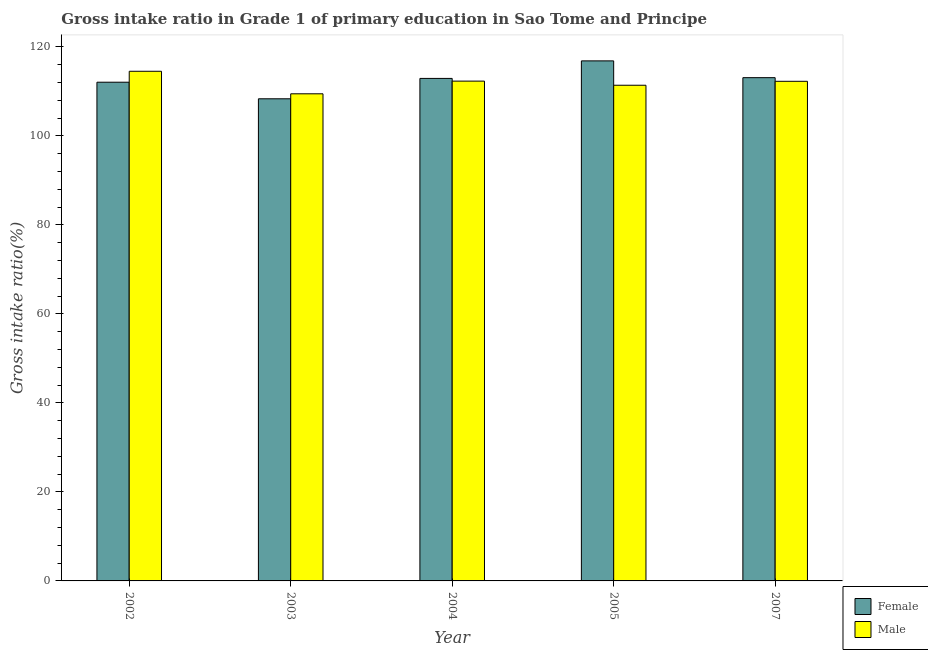How many different coloured bars are there?
Make the answer very short. 2. Are the number of bars on each tick of the X-axis equal?
Provide a succinct answer. Yes. How many bars are there on the 4th tick from the left?
Give a very brief answer. 2. How many bars are there on the 2nd tick from the right?
Offer a terse response. 2. In how many cases, is the number of bars for a given year not equal to the number of legend labels?
Your answer should be compact. 0. What is the gross intake ratio(male) in 2007?
Offer a very short reply. 112.26. Across all years, what is the maximum gross intake ratio(female)?
Provide a short and direct response. 116.85. Across all years, what is the minimum gross intake ratio(female)?
Keep it short and to the point. 108.33. What is the total gross intake ratio(male) in the graph?
Your answer should be very brief. 559.91. What is the difference between the gross intake ratio(male) in 2002 and that in 2007?
Keep it short and to the point. 2.26. What is the difference between the gross intake ratio(female) in 2007 and the gross intake ratio(male) in 2002?
Your answer should be very brief. 1.02. What is the average gross intake ratio(male) per year?
Give a very brief answer. 111.98. What is the ratio of the gross intake ratio(female) in 2003 to that in 2007?
Make the answer very short. 0.96. What is the difference between the highest and the second highest gross intake ratio(female)?
Provide a succinct answer. 3.77. What is the difference between the highest and the lowest gross intake ratio(female)?
Your answer should be compact. 8.52. In how many years, is the gross intake ratio(female) greater than the average gross intake ratio(female) taken over all years?
Your answer should be compact. 3. What does the 2nd bar from the left in 2004 represents?
Provide a short and direct response. Male. Are the values on the major ticks of Y-axis written in scientific E-notation?
Provide a short and direct response. No. What is the title of the graph?
Your answer should be compact. Gross intake ratio in Grade 1 of primary education in Sao Tome and Principe. What is the label or title of the Y-axis?
Ensure brevity in your answer.  Gross intake ratio(%). What is the Gross intake ratio(%) of Female in 2002?
Provide a short and direct response. 112.06. What is the Gross intake ratio(%) of Male in 2002?
Provide a short and direct response. 114.52. What is the Gross intake ratio(%) of Female in 2003?
Ensure brevity in your answer.  108.33. What is the Gross intake ratio(%) of Male in 2003?
Offer a very short reply. 109.45. What is the Gross intake ratio(%) of Female in 2004?
Your answer should be compact. 112.91. What is the Gross intake ratio(%) in Male in 2004?
Ensure brevity in your answer.  112.3. What is the Gross intake ratio(%) of Female in 2005?
Ensure brevity in your answer.  116.85. What is the Gross intake ratio(%) of Male in 2005?
Give a very brief answer. 111.38. What is the Gross intake ratio(%) of Female in 2007?
Offer a very short reply. 113.08. What is the Gross intake ratio(%) of Male in 2007?
Offer a terse response. 112.26. Across all years, what is the maximum Gross intake ratio(%) of Female?
Offer a terse response. 116.85. Across all years, what is the maximum Gross intake ratio(%) of Male?
Your response must be concise. 114.52. Across all years, what is the minimum Gross intake ratio(%) of Female?
Your answer should be very brief. 108.33. Across all years, what is the minimum Gross intake ratio(%) in Male?
Your answer should be compact. 109.45. What is the total Gross intake ratio(%) of Female in the graph?
Your response must be concise. 563.23. What is the total Gross intake ratio(%) in Male in the graph?
Offer a terse response. 559.91. What is the difference between the Gross intake ratio(%) of Female in 2002 and that in 2003?
Make the answer very short. 3.73. What is the difference between the Gross intake ratio(%) of Male in 2002 and that in 2003?
Your answer should be compact. 5.06. What is the difference between the Gross intake ratio(%) in Female in 2002 and that in 2004?
Provide a succinct answer. -0.85. What is the difference between the Gross intake ratio(%) in Male in 2002 and that in 2004?
Give a very brief answer. 2.21. What is the difference between the Gross intake ratio(%) in Female in 2002 and that in 2005?
Provide a succinct answer. -4.79. What is the difference between the Gross intake ratio(%) of Male in 2002 and that in 2005?
Keep it short and to the point. 3.14. What is the difference between the Gross intake ratio(%) of Female in 2002 and that in 2007?
Your response must be concise. -1.02. What is the difference between the Gross intake ratio(%) in Male in 2002 and that in 2007?
Ensure brevity in your answer.  2.26. What is the difference between the Gross intake ratio(%) of Female in 2003 and that in 2004?
Make the answer very short. -4.58. What is the difference between the Gross intake ratio(%) in Male in 2003 and that in 2004?
Offer a terse response. -2.85. What is the difference between the Gross intake ratio(%) in Female in 2003 and that in 2005?
Give a very brief answer. -8.52. What is the difference between the Gross intake ratio(%) of Male in 2003 and that in 2005?
Offer a terse response. -1.93. What is the difference between the Gross intake ratio(%) in Female in 2003 and that in 2007?
Provide a succinct answer. -4.75. What is the difference between the Gross intake ratio(%) in Male in 2003 and that in 2007?
Offer a terse response. -2.81. What is the difference between the Gross intake ratio(%) of Female in 2004 and that in 2005?
Keep it short and to the point. -3.94. What is the difference between the Gross intake ratio(%) in Male in 2004 and that in 2005?
Provide a succinct answer. 0.93. What is the difference between the Gross intake ratio(%) of Female in 2004 and that in 2007?
Provide a short and direct response. -0.17. What is the difference between the Gross intake ratio(%) in Male in 2004 and that in 2007?
Keep it short and to the point. 0.04. What is the difference between the Gross intake ratio(%) of Female in 2005 and that in 2007?
Ensure brevity in your answer.  3.77. What is the difference between the Gross intake ratio(%) in Male in 2005 and that in 2007?
Provide a short and direct response. -0.88. What is the difference between the Gross intake ratio(%) in Female in 2002 and the Gross intake ratio(%) in Male in 2003?
Your answer should be compact. 2.61. What is the difference between the Gross intake ratio(%) in Female in 2002 and the Gross intake ratio(%) in Male in 2004?
Keep it short and to the point. -0.25. What is the difference between the Gross intake ratio(%) of Female in 2002 and the Gross intake ratio(%) of Male in 2005?
Give a very brief answer. 0.68. What is the difference between the Gross intake ratio(%) of Female in 2002 and the Gross intake ratio(%) of Male in 2007?
Your answer should be compact. -0.2. What is the difference between the Gross intake ratio(%) of Female in 2003 and the Gross intake ratio(%) of Male in 2004?
Offer a very short reply. -3.97. What is the difference between the Gross intake ratio(%) of Female in 2003 and the Gross intake ratio(%) of Male in 2005?
Make the answer very short. -3.04. What is the difference between the Gross intake ratio(%) of Female in 2003 and the Gross intake ratio(%) of Male in 2007?
Your answer should be very brief. -3.93. What is the difference between the Gross intake ratio(%) in Female in 2004 and the Gross intake ratio(%) in Male in 2005?
Your answer should be very brief. 1.53. What is the difference between the Gross intake ratio(%) in Female in 2004 and the Gross intake ratio(%) in Male in 2007?
Your answer should be compact. 0.65. What is the difference between the Gross intake ratio(%) in Female in 2005 and the Gross intake ratio(%) in Male in 2007?
Offer a very short reply. 4.59. What is the average Gross intake ratio(%) in Female per year?
Your response must be concise. 112.65. What is the average Gross intake ratio(%) of Male per year?
Your answer should be very brief. 111.98. In the year 2002, what is the difference between the Gross intake ratio(%) of Female and Gross intake ratio(%) of Male?
Your response must be concise. -2.46. In the year 2003, what is the difference between the Gross intake ratio(%) in Female and Gross intake ratio(%) in Male?
Your response must be concise. -1.12. In the year 2004, what is the difference between the Gross intake ratio(%) in Female and Gross intake ratio(%) in Male?
Your response must be concise. 0.61. In the year 2005, what is the difference between the Gross intake ratio(%) in Female and Gross intake ratio(%) in Male?
Offer a very short reply. 5.47. In the year 2007, what is the difference between the Gross intake ratio(%) of Female and Gross intake ratio(%) of Male?
Provide a succinct answer. 0.82. What is the ratio of the Gross intake ratio(%) in Female in 2002 to that in 2003?
Make the answer very short. 1.03. What is the ratio of the Gross intake ratio(%) of Male in 2002 to that in 2003?
Give a very brief answer. 1.05. What is the ratio of the Gross intake ratio(%) in Male in 2002 to that in 2004?
Provide a short and direct response. 1.02. What is the ratio of the Gross intake ratio(%) in Male in 2002 to that in 2005?
Your response must be concise. 1.03. What is the ratio of the Gross intake ratio(%) of Female in 2002 to that in 2007?
Offer a terse response. 0.99. What is the ratio of the Gross intake ratio(%) of Male in 2002 to that in 2007?
Give a very brief answer. 1.02. What is the ratio of the Gross intake ratio(%) of Female in 2003 to that in 2004?
Keep it short and to the point. 0.96. What is the ratio of the Gross intake ratio(%) in Male in 2003 to that in 2004?
Your answer should be compact. 0.97. What is the ratio of the Gross intake ratio(%) of Female in 2003 to that in 2005?
Make the answer very short. 0.93. What is the ratio of the Gross intake ratio(%) in Male in 2003 to that in 2005?
Your answer should be very brief. 0.98. What is the ratio of the Gross intake ratio(%) of Female in 2003 to that in 2007?
Offer a terse response. 0.96. What is the ratio of the Gross intake ratio(%) of Male in 2003 to that in 2007?
Give a very brief answer. 0.97. What is the ratio of the Gross intake ratio(%) of Female in 2004 to that in 2005?
Provide a succinct answer. 0.97. What is the ratio of the Gross intake ratio(%) in Male in 2004 to that in 2005?
Give a very brief answer. 1.01. What is the ratio of the Gross intake ratio(%) in Female in 2005 to that in 2007?
Provide a short and direct response. 1.03. What is the ratio of the Gross intake ratio(%) in Male in 2005 to that in 2007?
Keep it short and to the point. 0.99. What is the difference between the highest and the second highest Gross intake ratio(%) of Female?
Make the answer very short. 3.77. What is the difference between the highest and the second highest Gross intake ratio(%) of Male?
Your answer should be very brief. 2.21. What is the difference between the highest and the lowest Gross intake ratio(%) in Female?
Offer a terse response. 8.52. What is the difference between the highest and the lowest Gross intake ratio(%) of Male?
Offer a very short reply. 5.06. 